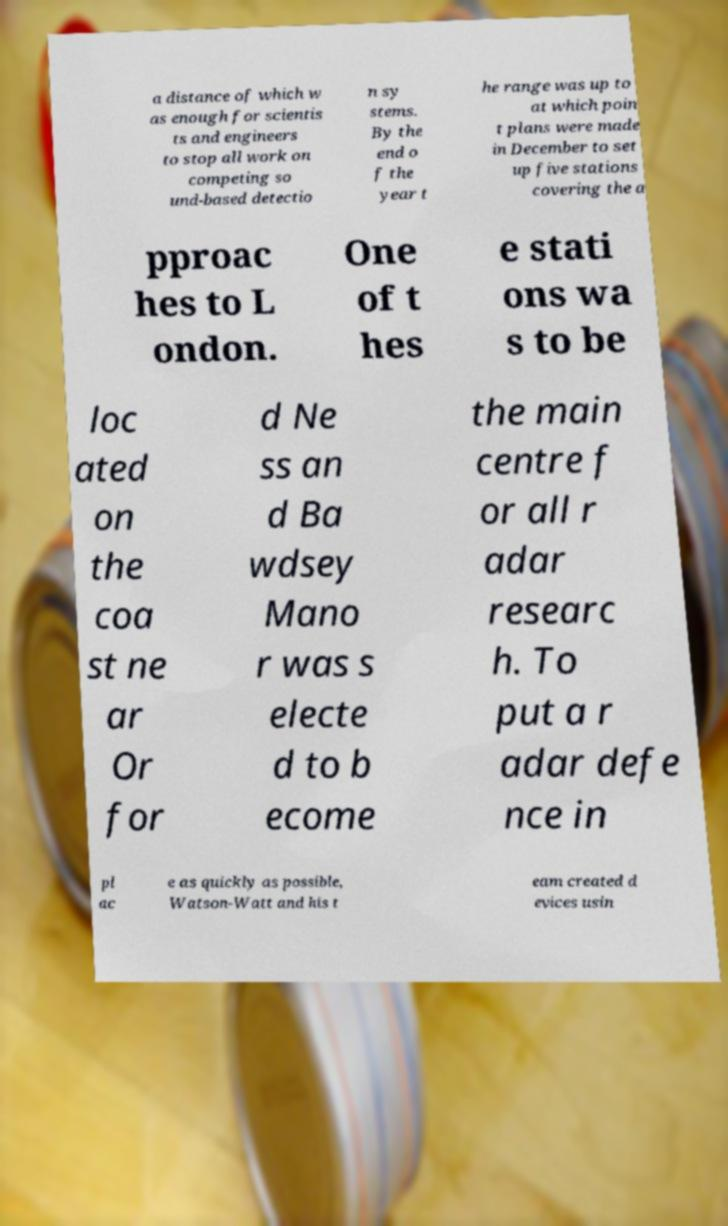Could you extract and type out the text from this image? a distance of which w as enough for scientis ts and engineers to stop all work on competing so und-based detectio n sy stems. By the end o f the year t he range was up to at which poin t plans were made in December to set up five stations covering the a pproac hes to L ondon. One of t hes e stati ons wa s to be loc ated on the coa st ne ar Or for d Ne ss an d Ba wdsey Mano r was s electe d to b ecome the main centre f or all r adar researc h. To put a r adar defe nce in pl ac e as quickly as possible, Watson-Watt and his t eam created d evices usin 